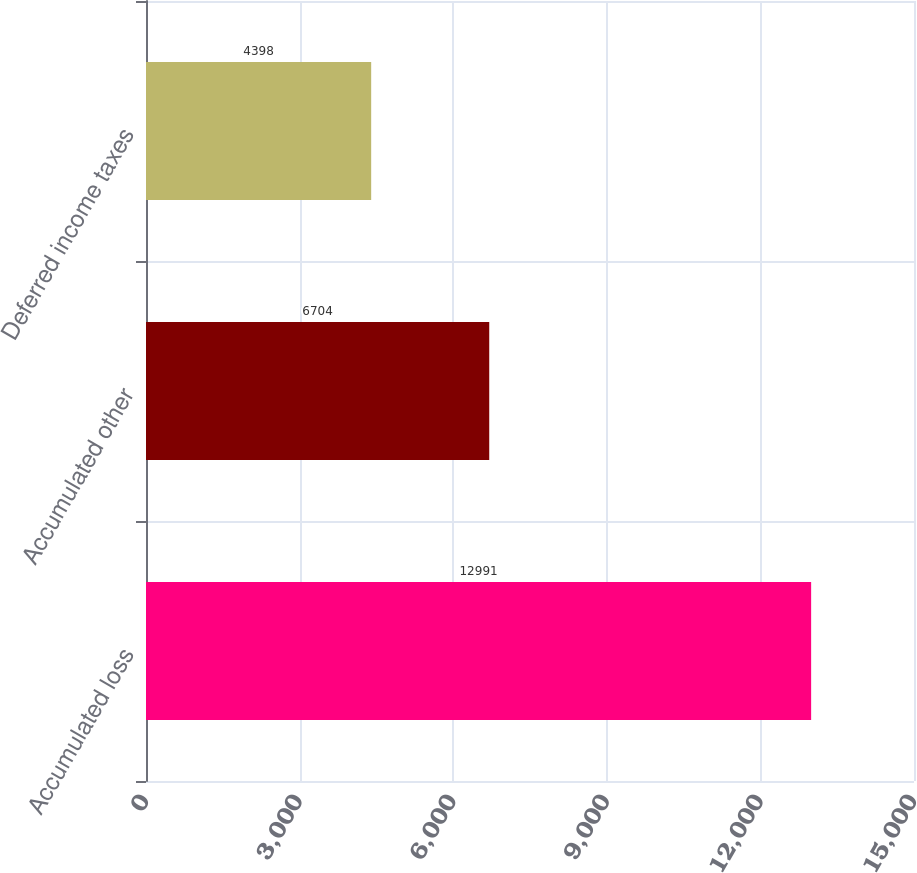<chart> <loc_0><loc_0><loc_500><loc_500><bar_chart><fcel>Accumulated loss<fcel>Accumulated other<fcel>Deferred income taxes<nl><fcel>12991<fcel>6704<fcel>4398<nl></chart> 